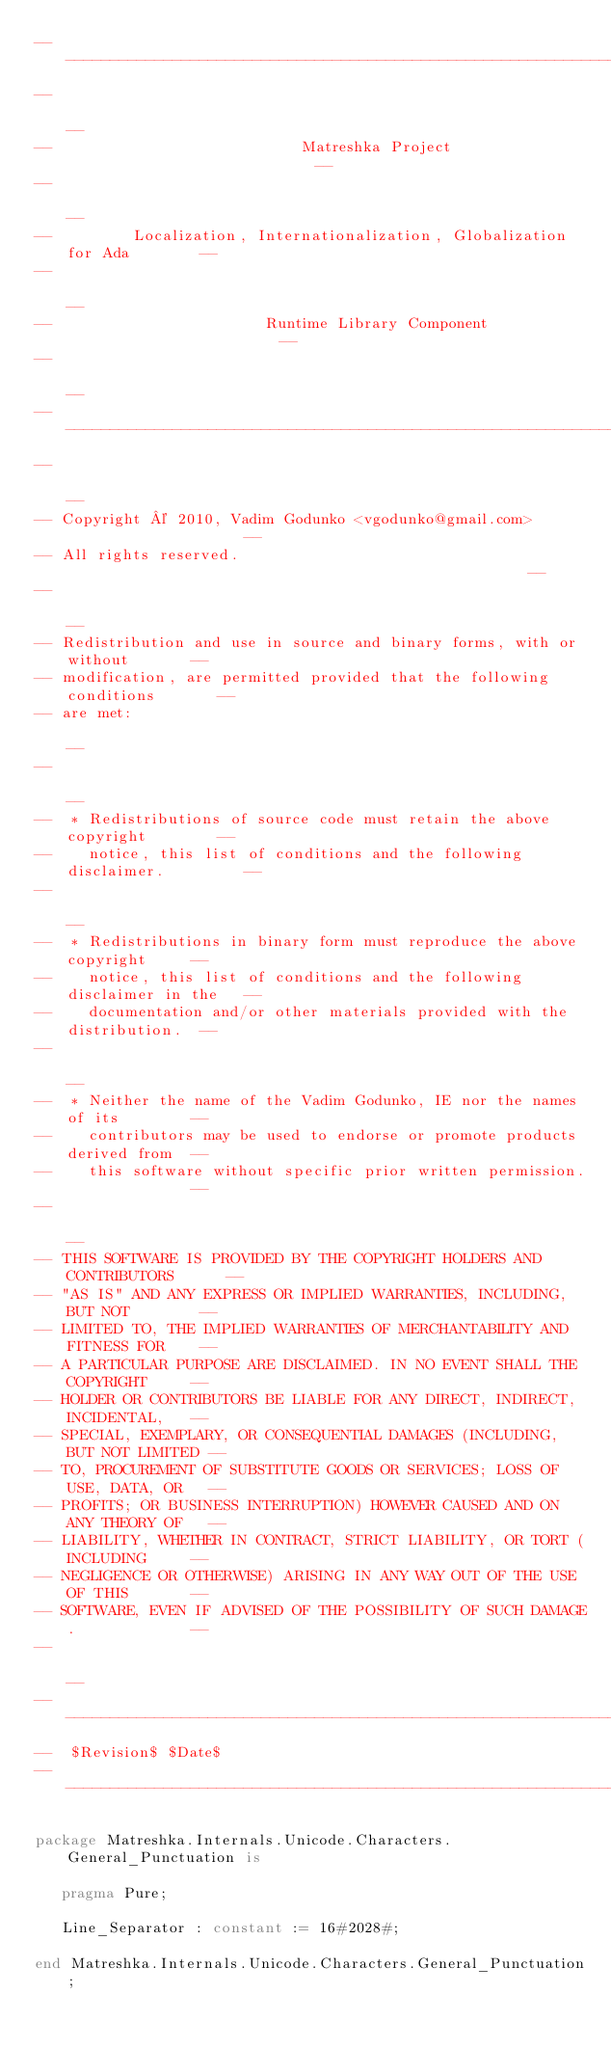<code> <loc_0><loc_0><loc_500><loc_500><_Ada_>------------------------------------------------------------------------------
--                                                                          --
--                            Matreshka Project                             --
--                                                                          --
--         Localization, Internationalization, Globalization for Ada        --
--                                                                          --
--                        Runtime Library Component                         --
--                                                                          --
------------------------------------------------------------------------------
--                                                                          --
-- Copyright © 2010, Vadim Godunko <vgodunko@gmail.com>                     --
-- All rights reserved.                                                     --
--                                                                          --
-- Redistribution and use in source and binary forms, with or without       --
-- modification, are permitted provided that the following conditions       --
-- are met:                                                                 --
--                                                                          --
--  * Redistributions of source code must retain the above copyright        --
--    notice, this list of conditions and the following disclaimer.         --
--                                                                          --
--  * Redistributions in binary form must reproduce the above copyright     --
--    notice, this list of conditions and the following disclaimer in the   --
--    documentation and/or other materials provided with the distribution.  --
--                                                                          --
--  * Neither the name of the Vadim Godunko, IE nor the names of its        --
--    contributors may be used to endorse or promote products derived from  --
--    this software without specific prior written permission.              --
--                                                                          --
-- THIS SOFTWARE IS PROVIDED BY THE COPYRIGHT HOLDERS AND CONTRIBUTORS      --
-- "AS IS" AND ANY EXPRESS OR IMPLIED WARRANTIES, INCLUDING, BUT NOT        --
-- LIMITED TO, THE IMPLIED WARRANTIES OF MERCHANTABILITY AND FITNESS FOR    --
-- A PARTICULAR PURPOSE ARE DISCLAIMED. IN NO EVENT SHALL THE COPYRIGHT     --
-- HOLDER OR CONTRIBUTORS BE LIABLE FOR ANY DIRECT, INDIRECT, INCIDENTAL,   --
-- SPECIAL, EXEMPLARY, OR CONSEQUENTIAL DAMAGES (INCLUDING, BUT NOT LIMITED --
-- TO, PROCUREMENT OF SUBSTITUTE GOODS OR SERVICES; LOSS OF USE, DATA, OR   --
-- PROFITS; OR BUSINESS INTERRUPTION) HOWEVER CAUSED AND ON ANY THEORY OF   --
-- LIABILITY, WHETHER IN CONTRACT, STRICT LIABILITY, OR TORT (INCLUDING     --
-- NEGLIGENCE OR OTHERWISE) ARISING IN ANY WAY OUT OF THE USE OF THIS       --
-- SOFTWARE, EVEN IF ADVISED OF THE POSSIBILITY OF SUCH DAMAGE.             --
--                                                                          --
------------------------------------------------------------------------------
--  $Revision$ $Date$
------------------------------------------------------------------------------

package Matreshka.Internals.Unicode.Characters.General_Punctuation is

   pragma Pure;

   Line_Separator : constant := 16#2028#;

end Matreshka.Internals.Unicode.Characters.General_Punctuation;
</code> 